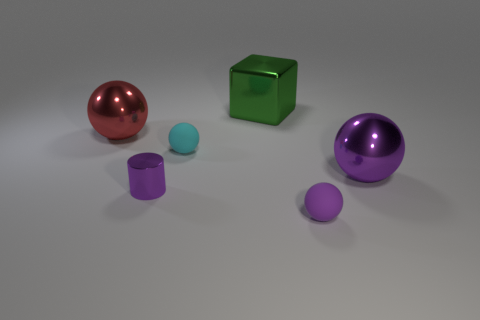There is a big red thing; are there any small purple cylinders behind it? Indeed, behind the large red sphere, there are two small purple cylinders positioned a slight distance apart from each other. 